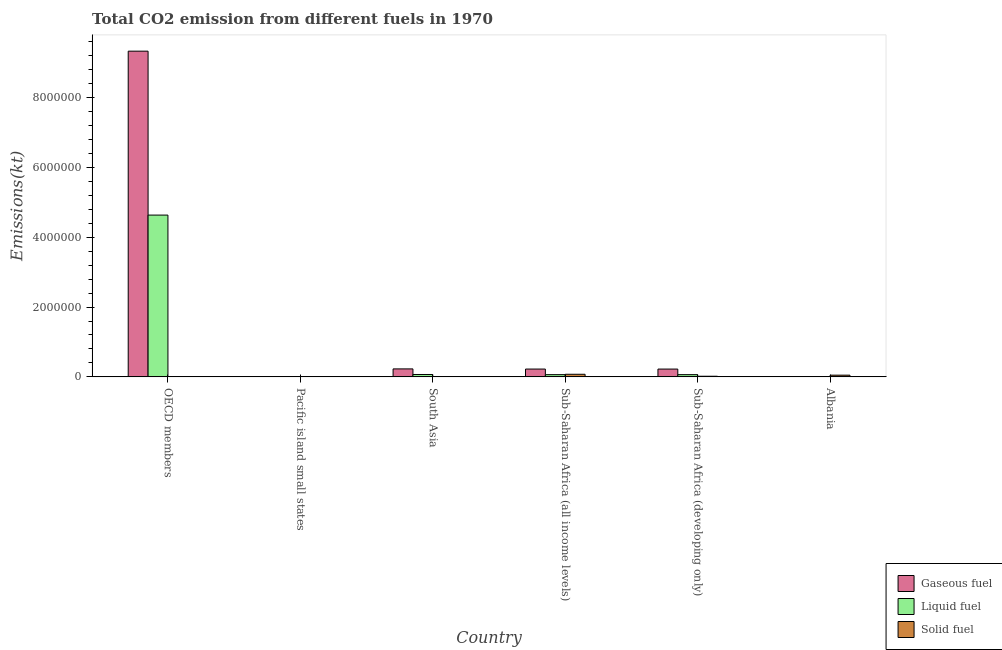How many groups of bars are there?
Give a very brief answer. 6. Are the number of bars on each tick of the X-axis equal?
Ensure brevity in your answer.  Yes. What is the label of the 6th group of bars from the left?
Your response must be concise. Albania. What is the amount of co2 emissions from liquid fuel in Albania?
Your answer should be very brief. 2482.56. Across all countries, what is the maximum amount of co2 emissions from liquid fuel?
Keep it short and to the point. 4.63e+06. Across all countries, what is the minimum amount of co2 emissions from liquid fuel?
Give a very brief answer. 864.69. In which country was the amount of co2 emissions from liquid fuel minimum?
Offer a terse response. Pacific island small states. What is the total amount of co2 emissions from gaseous fuel in the graph?
Provide a succinct answer. 1.00e+07. What is the difference between the amount of co2 emissions from gaseous fuel in South Asia and that in Sub-Saharan Africa (all income levels)?
Your answer should be compact. 4515.06. What is the difference between the amount of co2 emissions from solid fuel in Pacific island small states and the amount of co2 emissions from gaseous fuel in OECD members?
Your answer should be very brief. -9.33e+06. What is the average amount of co2 emissions from liquid fuel per country?
Your answer should be very brief. 8.06e+05. What is the difference between the amount of co2 emissions from liquid fuel and amount of co2 emissions from gaseous fuel in OECD members?
Provide a succinct answer. -4.70e+06. What is the ratio of the amount of co2 emissions from solid fuel in Pacific island small states to that in Sub-Saharan Africa (developing only)?
Provide a succinct answer. 0. What is the difference between the highest and the second highest amount of co2 emissions from liquid fuel?
Offer a very short reply. 4.57e+06. What is the difference between the highest and the lowest amount of co2 emissions from solid fuel?
Provide a succinct answer. 7.43e+04. In how many countries, is the amount of co2 emissions from gaseous fuel greater than the average amount of co2 emissions from gaseous fuel taken over all countries?
Provide a short and direct response. 1. What does the 1st bar from the left in Sub-Saharan Africa (developing only) represents?
Keep it short and to the point. Gaseous fuel. What does the 1st bar from the right in South Asia represents?
Make the answer very short. Solid fuel. Is it the case that in every country, the sum of the amount of co2 emissions from gaseous fuel and amount of co2 emissions from liquid fuel is greater than the amount of co2 emissions from solid fuel?
Give a very brief answer. No. How many bars are there?
Provide a succinct answer. 18. Are all the bars in the graph horizontal?
Keep it short and to the point. No. Does the graph contain grids?
Make the answer very short. No. How are the legend labels stacked?
Provide a short and direct response. Vertical. What is the title of the graph?
Provide a succinct answer. Total CO2 emission from different fuels in 1970. Does "Gaseous fuel" appear as one of the legend labels in the graph?
Your response must be concise. Yes. What is the label or title of the Y-axis?
Offer a very short reply. Emissions(kt). What is the Emissions(kt) in Gaseous fuel in OECD members?
Offer a very short reply. 9.33e+06. What is the Emissions(kt) in Liquid fuel in OECD members?
Keep it short and to the point. 4.63e+06. What is the Emissions(kt) of Solid fuel in OECD members?
Offer a very short reply. 971.75. What is the Emissions(kt) of Gaseous fuel in Pacific island small states?
Your answer should be very brief. 891.27. What is the Emissions(kt) in Liquid fuel in Pacific island small states?
Give a very brief answer. 864.69. What is the Emissions(kt) in Solid fuel in Pacific island small states?
Your answer should be compact. 47.67. What is the Emissions(kt) in Gaseous fuel in South Asia?
Offer a terse response. 2.28e+05. What is the Emissions(kt) of Liquid fuel in South Asia?
Ensure brevity in your answer.  6.83e+04. What is the Emissions(kt) of Solid fuel in South Asia?
Your response must be concise. 3289.3. What is the Emissions(kt) in Gaseous fuel in Sub-Saharan Africa (all income levels)?
Keep it short and to the point. 2.24e+05. What is the Emissions(kt) in Liquid fuel in Sub-Saharan Africa (all income levels)?
Your answer should be compact. 6.39e+04. What is the Emissions(kt) of Solid fuel in Sub-Saharan Africa (all income levels)?
Provide a short and direct response. 7.44e+04. What is the Emissions(kt) in Gaseous fuel in Sub-Saharan Africa (developing only)?
Provide a succinct answer. 2.24e+05. What is the Emissions(kt) in Liquid fuel in Sub-Saharan Africa (developing only)?
Ensure brevity in your answer.  6.38e+04. What is the Emissions(kt) in Solid fuel in Sub-Saharan Africa (developing only)?
Make the answer very short. 1.78e+04. What is the Emissions(kt) in Gaseous fuel in Albania?
Provide a short and direct response. 3744.01. What is the Emissions(kt) in Liquid fuel in Albania?
Your response must be concise. 2482.56. What is the Emissions(kt) in Solid fuel in Albania?
Make the answer very short. 4.90e+04. Across all countries, what is the maximum Emissions(kt) in Gaseous fuel?
Provide a succinct answer. 9.33e+06. Across all countries, what is the maximum Emissions(kt) in Liquid fuel?
Ensure brevity in your answer.  4.63e+06. Across all countries, what is the maximum Emissions(kt) in Solid fuel?
Make the answer very short. 7.44e+04. Across all countries, what is the minimum Emissions(kt) in Gaseous fuel?
Your answer should be compact. 891.27. Across all countries, what is the minimum Emissions(kt) of Liquid fuel?
Your answer should be very brief. 864.69. Across all countries, what is the minimum Emissions(kt) of Solid fuel?
Your answer should be very brief. 47.67. What is the total Emissions(kt) in Gaseous fuel in the graph?
Provide a succinct answer. 1.00e+07. What is the total Emissions(kt) of Liquid fuel in the graph?
Your answer should be very brief. 4.83e+06. What is the total Emissions(kt) of Solid fuel in the graph?
Ensure brevity in your answer.  1.46e+05. What is the difference between the Emissions(kt) of Gaseous fuel in OECD members and that in Pacific island small states?
Provide a succinct answer. 9.33e+06. What is the difference between the Emissions(kt) in Liquid fuel in OECD members and that in Pacific island small states?
Your response must be concise. 4.63e+06. What is the difference between the Emissions(kt) of Solid fuel in OECD members and that in Pacific island small states?
Make the answer very short. 924.08. What is the difference between the Emissions(kt) in Gaseous fuel in OECD members and that in South Asia?
Give a very brief answer. 9.10e+06. What is the difference between the Emissions(kt) in Liquid fuel in OECD members and that in South Asia?
Ensure brevity in your answer.  4.57e+06. What is the difference between the Emissions(kt) in Solid fuel in OECD members and that in South Asia?
Your answer should be compact. -2317.54. What is the difference between the Emissions(kt) of Gaseous fuel in OECD members and that in Sub-Saharan Africa (all income levels)?
Your answer should be compact. 9.11e+06. What is the difference between the Emissions(kt) in Liquid fuel in OECD members and that in Sub-Saharan Africa (all income levels)?
Your response must be concise. 4.57e+06. What is the difference between the Emissions(kt) of Solid fuel in OECD members and that in Sub-Saharan Africa (all income levels)?
Your answer should be very brief. -7.34e+04. What is the difference between the Emissions(kt) in Gaseous fuel in OECD members and that in Sub-Saharan Africa (developing only)?
Offer a terse response. 9.11e+06. What is the difference between the Emissions(kt) in Liquid fuel in OECD members and that in Sub-Saharan Africa (developing only)?
Provide a succinct answer. 4.57e+06. What is the difference between the Emissions(kt) in Solid fuel in OECD members and that in Sub-Saharan Africa (developing only)?
Make the answer very short. -1.68e+04. What is the difference between the Emissions(kt) in Gaseous fuel in OECD members and that in Albania?
Provide a succinct answer. 9.33e+06. What is the difference between the Emissions(kt) of Liquid fuel in OECD members and that in Albania?
Give a very brief answer. 4.63e+06. What is the difference between the Emissions(kt) of Solid fuel in OECD members and that in Albania?
Offer a very short reply. -4.81e+04. What is the difference between the Emissions(kt) in Gaseous fuel in Pacific island small states and that in South Asia?
Provide a short and direct response. -2.27e+05. What is the difference between the Emissions(kt) of Liquid fuel in Pacific island small states and that in South Asia?
Offer a very short reply. -6.74e+04. What is the difference between the Emissions(kt) in Solid fuel in Pacific island small states and that in South Asia?
Give a very brief answer. -3241.63. What is the difference between the Emissions(kt) of Gaseous fuel in Pacific island small states and that in Sub-Saharan Africa (all income levels)?
Your answer should be compact. -2.23e+05. What is the difference between the Emissions(kt) of Liquid fuel in Pacific island small states and that in Sub-Saharan Africa (all income levels)?
Offer a very short reply. -6.30e+04. What is the difference between the Emissions(kt) in Solid fuel in Pacific island small states and that in Sub-Saharan Africa (all income levels)?
Make the answer very short. -7.43e+04. What is the difference between the Emissions(kt) of Gaseous fuel in Pacific island small states and that in Sub-Saharan Africa (developing only)?
Make the answer very short. -2.23e+05. What is the difference between the Emissions(kt) of Liquid fuel in Pacific island small states and that in Sub-Saharan Africa (developing only)?
Provide a short and direct response. -6.30e+04. What is the difference between the Emissions(kt) in Solid fuel in Pacific island small states and that in Sub-Saharan Africa (developing only)?
Provide a short and direct response. -1.78e+04. What is the difference between the Emissions(kt) of Gaseous fuel in Pacific island small states and that in Albania?
Offer a terse response. -2852.74. What is the difference between the Emissions(kt) of Liquid fuel in Pacific island small states and that in Albania?
Your answer should be very brief. -1617.87. What is the difference between the Emissions(kt) of Solid fuel in Pacific island small states and that in Albania?
Provide a succinct answer. -4.90e+04. What is the difference between the Emissions(kt) in Gaseous fuel in South Asia and that in Sub-Saharan Africa (all income levels)?
Make the answer very short. 4515.06. What is the difference between the Emissions(kt) of Liquid fuel in South Asia and that in Sub-Saharan Africa (all income levels)?
Provide a succinct answer. 4375.04. What is the difference between the Emissions(kt) in Solid fuel in South Asia and that in Sub-Saharan Africa (all income levels)?
Keep it short and to the point. -7.11e+04. What is the difference between the Emissions(kt) of Gaseous fuel in South Asia and that in Sub-Saharan Africa (developing only)?
Make the answer very short. 4576.47. What is the difference between the Emissions(kt) of Liquid fuel in South Asia and that in Sub-Saharan Africa (developing only)?
Provide a succinct answer. 4437.73. What is the difference between the Emissions(kt) in Solid fuel in South Asia and that in Sub-Saharan Africa (developing only)?
Offer a terse response. -1.45e+04. What is the difference between the Emissions(kt) of Gaseous fuel in South Asia and that in Albania?
Keep it short and to the point. 2.25e+05. What is the difference between the Emissions(kt) of Liquid fuel in South Asia and that in Albania?
Provide a succinct answer. 6.58e+04. What is the difference between the Emissions(kt) of Solid fuel in South Asia and that in Albania?
Offer a very short reply. -4.57e+04. What is the difference between the Emissions(kt) of Gaseous fuel in Sub-Saharan Africa (all income levels) and that in Sub-Saharan Africa (developing only)?
Provide a succinct answer. 61.41. What is the difference between the Emissions(kt) of Liquid fuel in Sub-Saharan Africa (all income levels) and that in Sub-Saharan Africa (developing only)?
Make the answer very short. 62.69. What is the difference between the Emissions(kt) of Solid fuel in Sub-Saharan Africa (all income levels) and that in Sub-Saharan Africa (developing only)?
Offer a terse response. 5.65e+04. What is the difference between the Emissions(kt) of Gaseous fuel in Sub-Saharan Africa (all income levels) and that in Albania?
Ensure brevity in your answer.  2.20e+05. What is the difference between the Emissions(kt) in Liquid fuel in Sub-Saharan Africa (all income levels) and that in Albania?
Make the answer very short. 6.14e+04. What is the difference between the Emissions(kt) in Solid fuel in Sub-Saharan Africa (all income levels) and that in Albania?
Give a very brief answer. 2.53e+04. What is the difference between the Emissions(kt) of Gaseous fuel in Sub-Saharan Africa (developing only) and that in Albania?
Keep it short and to the point. 2.20e+05. What is the difference between the Emissions(kt) of Liquid fuel in Sub-Saharan Africa (developing only) and that in Albania?
Keep it short and to the point. 6.13e+04. What is the difference between the Emissions(kt) of Solid fuel in Sub-Saharan Africa (developing only) and that in Albania?
Keep it short and to the point. -3.12e+04. What is the difference between the Emissions(kt) in Gaseous fuel in OECD members and the Emissions(kt) in Liquid fuel in Pacific island small states?
Your answer should be very brief. 9.33e+06. What is the difference between the Emissions(kt) in Gaseous fuel in OECD members and the Emissions(kt) in Solid fuel in Pacific island small states?
Your answer should be very brief. 9.33e+06. What is the difference between the Emissions(kt) in Liquid fuel in OECD members and the Emissions(kt) in Solid fuel in Pacific island small states?
Ensure brevity in your answer.  4.63e+06. What is the difference between the Emissions(kt) of Gaseous fuel in OECD members and the Emissions(kt) of Liquid fuel in South Asia?
Your answer should be very brief. 9.26e+06. What is the difference between the Emissions(kt) in Gaseous fuel in OECD members and the Emissions(kt) in Solid fuel in South Asia?
Give a very brief answer. 9.33e+06. What is the difference between the Emissions(kt) of Liquid fuel in OECD members and the Emissions(kt) of Solid fuel in South Asia?
Your answer should be compact. 4.63e+06. What is the difference between the Emissions(kt) of Gaseous fuel in OECD members and the Emissions(kt) of Liquid fuel in Sub-Saharan Africa (all income levels)?
Provide a succinct answer. 9.27e+06. What is the difference between the Emissions(kt) of Gaseous fuel in OECD members and the Emissions(kt) of Solid fuel in Sub-Saharan Africa (all income levels)?
Offer a very short reply. 9.26e+06. What is the difference between the Emissions(kt) in Liquid fuel in OECD members and the Emissions(kt) in Solid fuel in Sub-Saharan Africa (all income levels)?
Provide a short and direct response. 4.56e+06. What is the difference between the Emissions(kt) in Gaseous fuel in OECD members and the Emissions(kt) in Liquid fuel in Sub-Saharan Africa (developing only)?
Provide a short and direct response. 9.27e+06. What is the difference between the Emissions(kt) of Gaseous fuel in OECD members and the Emissions(kt) of Solid fuel in Sub-Saharan Africa (developing only)?
Give a very brief answer. 9.31e+06. What is the difference between the Emissions(kt) of Liquid fuel in OECD members and the Emissions(kt) of Solid fuel in Sub-Saharan Africa (developing only)?
Your answer should be compact. 4.62e+06. What is the difference between the Emissions(kt) of Gaseous fuel in OECD members and the Emissions(kt) of Liquid fuel in Albania?
Your answer should be compact. 9.33e+06. What is the difference between the Emissions(kt) in Gaseous fuel in OECD members and the Emissions(kt) in Solid fuel in Albania?
Ensure brevity in your answer.  9.28e+06. What is the difference between the Emissions(kt) in Liquid fuel in OECD members and the Emissions(kt) in Solid fuel in Albania?
Offer a very short reply. 4.59e+06. What is the difference between the Emissions(kt) in Gaseous fuel in Pacific island small states and the Emissions(kt) in Liquid fuel in South Asia?
Provide a short and direct response. -6.74e+04. What is the difference between the Emissions(kt) of Gaseous fuel in Pacific island small states and the Emissions(kt) of Solid fuel in South Asia?
Your answer should be compact. -2398.03. What is the difference between the Emissions(kt) of Liquid fuel in Pacific island small states and the Emissions(kt) of Solid fuel in South Asia?
Make the answer very short. -2424.61. What is the difference between the Emissions(kt) in Gaseous fuel in Pacific island small states and the Emissions(kt) in Liquid fuel in Sub-Saharan Africa (all income levels)?
Keep it short and to the point. -6.30e+04. What is the difference between the Emissions(kt) in Gaseous fuel in Pacific island small states and the Emissions(kt) in Solid fuel in Sub-Saharan Africa (all income levels)?
Offer a terse response. -7.35e+04. What is the difference between the Emissions(kt) in Liquid fuel in Pacific island small states and the Emissions(kt) in Solid fuel in Sub-Saharan Africa (all income levels)?
Ensure brevity in your answer.  -7.35e+04. What is the difference between the Emissions(kt) in Gaseous fuel in Pacific island small states and the Emissions(kt) in Liquid fuel in Sub-Saharan Africa (developing only)?
Provide a succinct answer. -6.29e+04. What is the difference between the Emissions(kt) in Gaseous fuel in Pacific island small states and the Emissions(kt) in Solid fuel in Sub-Saharan Africa (developing only)?
Provide a short and direct response. -1.69e+04. What is the difference between the Emissions(kt) of Liquid fuel in Pacific island small states and the Emissions(kt) of Solid fuel in Sub-Saharan Africa (developing only)?
Provide a succinct answer. -1.69e+04. What is the difference between the Emissions(kt) in Gaseous fuel in Pacific island small states and the Emissions(kt) in Liquid fuel in Albania?
Make the answer very short. -1591.29. What is the difference between the Emissions(kt) in Gaseous fuel in Pacific island small states and the Emissions(kt) in Solid fuel in Albania?
Your answer should be compact. -4.81e+04. What is the difference between the Emissions(kt) in Liquid fuel in Pacific island small states and the Emissions(kt) in Solid fuel in Albania?
Ensure brevity in your answer.  -4.82e+04. What is the difference between the Emissions(kt) in Gaseous fuel in South Asia and the Emissions(kt) in Liquid fuel in Sub-Saharan Africa (all income levels)?
Your answer should be compact. 1.64e+05. What is the difference between the Emissions(kt) in Gaseous fuel in South Asia and the Emissions(kt) in Solid fuel in Sub-Saharan Africa (all income levels)?
Offer a very short reply. 1.54e+05. What is the difference between the Emissions(kt) in Liquid fuel in South Asia and the Emissions(kt) in Solid fuel in Sub-Saharan Africa (all income levels)?
Keep it short and to the point. -6091.52. What is the difference between the Emissions(kt) in Gaseous fuel in South Asia and the Emissions(kt) in Liquid fuel in Sub-Saharan Africa (developing only)?
Provide a succinct answer. 1.64e+05. What is the difference between the Emissions(kt) in Gaseous fuel in South Asia and the Emissions(kt) in Solid fuel in Sub-Saharan Africa (developing only)?
Offer a very short reply. 2.10e+05. What is the difference between the Emissions(kt) in Liquid fuel in South Asia and the Emissions(kt) in Solid fuel in Sub-Saharan Africa (developing only)?
Provide a succinct answer. 5.04e+04. What is the difference between the Emissions(kt) in Gaseous fuel in South Asia and the Emissions(kt) in Liquid fuel in Albania?
Give a very brief answer. 2.26e+05. What is the difference between the Emissions(kt) of Gaseous fuel in South Asia and the Emissions(kt) of Solid fuel in Albania?
Your answer should be very brief. 1.79e+05. What is the difference between the Emissions(kt) in Liquid fuel in South Asia and the Emissions(kt) in Solid fuel in Albania?
Ensure brevity in your answer.  1.92e+04. What is the difference between the Emissions(kt) of Gaseous fuel in Sub-Saharan Africa (all income levels) and the Emissions(kt) of Liquid fuel in Sub-Saharan Africa (developing only)?
Ensure brevity in your answer.  1.60e+05. What is the difference between the Emissions(kt) in Gaseous fuel in Sub-Saharan Africa (all income levels) and the Emissions(kt) in Solid fuel in Sub-Saharan Africa (developing only)?
Offer a very short reply. 2.06e+05. What is the difference between the Emissions(kt) of Liquid fuel in Sub-Saharan Africa (all income levels) and the Emissions(kt) of Solid fuel in Sub-Saharan Africa (developing only)?
Provide a succinct answer. 4.61e+04. What is the difference between the Emissions(kt) of Gaseous fuel in Sub-Saharan Africa (all income levels) and the Emissions(kt) of Liquid fuel in Albania?
Provide a succinct answer. 2.21e+05. What is the difference between the Emissions(kt) of Gaseous fuel in Sub-Saharan Africa (all income levels) and the Emissions(kt) of Solid fuel in Albania?
Keep it short and to the point. 1.75e+05. What is the difference between the Emissions(kt) in Liquid fuel in Sub-Saharan Africa (all income levels) and the Emissions(kt) in Solid fuel in Albania?
Your answer should be very brief. 1.49e+04. What is the difference between the Emissions(kt) in Gaseous fuel in Sub-Saharan Africa (developing only) and the Emissions(kt) in Liquid fuel in Albania?
Ensure brevity in your answer.  2.21e+05. What is the difference between the Emissions(kt) of Gaseous fuel in Sub-Saharan Africa (developing only) and the Emissions(kt) of Solid fuel in Albania?
Offer a very short reply. 1.75e+05. What is the difference between the Emissions(kt) in Liquid fuel in Sub-Saharan Africa (developing only) and the Emissions(kt) in Solid fuel in Albania?
Keep it short and to the point. 1.48e+04. What is the average Emissions(kt) in Gaseous fuel per country?
Offer a terse response. 1.67e+06. What is the average Emissions(kt) in Liquid fuel per country?
Your answer should be compact. 8.06e+05. What is the average Emissions(kt) in Solid fuel per country?
Your answer should be very brief. 2.43e+04. What is the difference between the Emissions(kt) of Gaseous fuel and Emissions(kt) of Liquid fuel in OECD members?
Ensure brevity in your answer.  4.70e+06. What is the difference between the Emissions(kt) of Gaseous fuel and Emissions(kt) of Solid fuel in OECD members?
Your answer should be compact. 9.33e+06. What is the difference between the Emissions(kt) in Liquid fuel and Emissions(kt) in Solid fuel in OECD members?
Give a very brief answer. 4.63e+06. What is the difference between the Emissions(kt) of Gaseous fuel and Emissions(kt) of Liquid fuel in Pacific island small states?
Offer a terse response. 26.58. What is the difference between the Emissions(kt) in Gaseous fuel and Emissions(kt) in Solid fuel in Pacific island small states?
Your answer should be very brief. 843.6. What is the difference between the Emissions(kt) of Liquid fuel and Emissions(kt) of Solid fuel in Pacific island small states?
Keep it short and to the point. 817.02. What is the difference between the Emissions(kt) of Gaseous fuel and Emissions(kt) of Liquid fuel in South Asia?
Your answer should be very brief. 1.60e+05. What is the difference between the Emissions(kt) of Gaseous fuel and Emissions(kt) of Solid fuel in South Asia?
Make the answer very short. 2.25e+05. What is the difference between the Emissions(kt) of Liquid fuel and Emissions(kt) of Solid fuel in South Asia?
Ensure brevity in your answer.  6.50e+04. What is the difference between the Emissions(kt) in Gaseous fuel and Emissions(kt) in Liquid fuel in Sub-Saharan Africa (all income levels)?
Your answer should be very brief. 1.60e+05. What is the difference between the Emissions(kt) in Gaseous fuel and Emissions(kt) in Solid fuel in Sub-Saharan Africa (all income levels)?
Keep it short and to the point. 1.49e+05. What is the difference between the Emissions(kt) in Liquid fuel and Emissions(kt) in Solid fuel in Sub-Saharan Africa (all income levels)?
Provide a short and direct response. -1.05e+04. What is the difference between the Emissions(kt) of Gaseous fuel and Emissions(kt) of Liquid fuel in Sub-Saharan Africa (developing only)?
Provide a succinct answer. 1.60e+05. What is the difference between the Emissions(kt) of Gaseous fuel and Emissions(kt) of Solid fuel in Sub-Saharan Africa (developing only)?
Your answer should be compact. 2.06e+05. What is the difference between the Emissions(kt) in Liquid fuel and Emissions(kt) in Solid fuel in Sub-Saharan Africa (developing only)?
Keep it short and to the point. 4.60e+04. What is the difference between the Emissions(kt) in Gaseous fuel and Emissions(kt) in Liquid fuel in Albania?
Give a very brief answer. 1261.45. What is the difference between the Emissions(kt) in Gaseous fuel and Emissions(kt) in Solid fuel in Albania?
Your answer should be compact. -4.53e+04. What is the difference between the Emissions(kt) of Liquid fuel and Emissions(kt) of Solid fuel in Albania?
Offer a terse response. -4.66e+04. What is the ratio of the Emissions(kt) in Gaseous fuel in OECD members to that in Pacific island small states?
Offer a very short reply. 1.05e+04. What is the ratio of the Emissions(kt) in Liquid fuel in OECD members to that in Pacific island small states?
Offer a very short reply. 5359.9. What is the ratio of the Emissions(kt) of Solid fuel in OECD members to that in Pacific island small states?
Provide a succinct answer. 20.38. What is the ratio of the Emissions(kt) of Gaseous fuel in OECD members to that in South Asia?
Your response must be concise. 40.88. What is the ratio of the Emissions(kt) in Liquid fuel in OECD members to that in South Asia?
Offer a terse response. 67.89. What is the ratio of the Emissions(kt) of Solid fuel in OECD members to that in South Asia?
Offer a very short reply. 0.3. What is the ratio of the Emissions(kt) in Gaseous fuel in OECD members to that in Sub-Saharan Africa (all income levels)?
Provide a succinct answer. 41.7. What is the ratio of the Emissions(kt) of Liquid fuel in OECD members to that in Sub-Saharan Africa (all income levels)?
Offer a very short reply. 72.54. What is the ratio of the Emissions(kt) of Solid fuel in OECD members to that in Sub-Saharan Africa (all income levels)?
Your response must be concise. 0.01. What is the ratio of the Emissions(kt) of Gaseous fuel in OECD members to that in Sub-Saharan Africa (developing only)?
Provide a succinct answer. 41.71. What is the ratio of the Emissions(kt) in Liquid fuel in OECD members to that in Sub-Saharan Africa (developing only)?
Provide a short and direct response. 72.61. What is the ratio of the Emissions(kt) of Solid fuel in OECD members to that in Sub-Saharan Africa (developing only)?
Provide a succinct answer. 0.05. What is the ratio of the Emissions(kt) in Gaseous fuel in OECD members to that in Albania?
Provide a short and direct response. 2492.05. What is the ratio of the Emissions(kt) of Liquid fuel in OECD members to that in Albania?
Provide a succinct answer. 1866.88. What is the ratio of the Emissions(kt) in Solid fuel in OECD members to that in Albania?
Ensure brevity in your answer.  0.02. What is the ratio of the Emissions(kt) in Gaseous fuel in Pacific island small states to that in South Asia?
Provide a short and direct response. 0. What is the ratio of the Emissions(kt) of Liquid fuel in Pacific island small states to that in South Asia?
Ensure brevity in your answer.  0.01. What is the ratio of the Emissions(kt) in Solid fuel in Pacific island small states to that in South Asia?
Give a very brief answer. 0.01. What is the ratio of the Emissions(kt) of Gaseous fuel in Pacific island small states to that in Sub-Saharan Africa (all income levels)?
Keep it short and to the point. 0. What is the ratio of the Emissions(kt) in Liquid fuel in Pacific island small states to that in Sub-Saharan Africa (all income levels)?
Provide a succinct answer. 0.01. What is the ratio of the Emissions(kt) of Solid fuel in Pacific island small states to that in Sub-Saharan Africa (all income levels)?
Provide a short and direct response. 0. What is the ratio of the Emissions(kt) of Gaseous fuel in Pacific island small states to that in Sub-Saharan Africa (developing only)?
Offer a terse response. 0. What is the ratio of the Emissions(kt) of Liquid fuel in Pacific island small states to that in Sub-Saharan Africa (developing only)?
Ensure brevity in your answer.  0.01. What is the ratio of the Emissions(kt) of Solid fuel in Pacific island small states to that in Sub-Saharan Africa (developing only)?
Provide a short and direct response. 0. What is the ratio of the Emissions(kt) of Gaseous fuel in Pacific island small states to that in Albania?
Give a very brief answer. 0.24. What is the ratio of the Emissions(kt) of Liquid fuel in Pacific island small states to that in Albania?
Offer a very short reply. 0.35. What is the ratio of the Emissions(kt) of Gaseous fuel in South Asia to that in Sub-Saharan Africa (all income levels)?
Make the answer very short. 1.02. What is the ratio of the Emissions(kt) of Liquid fuel in South Asia to that in Sub-Saharan Africa (all income levels)?
Offer a very short reply. 1.07. What is the ratio of the Emissions(kt) in Solid fuel in South Asia to that in Sub-Saharan Africa (all income levels)?
Ensure brevity in your answer.  0.04. What is the ratio of the Emissions(kt) of Gaseous fuel in South Asia to that in Sub-Saharan Africa (developing only)?
Offer a very short reply. 1.02. What is the ratio of the Emissions(kt) in Liquid fuel in South Asia to that in Sub-Saharan Africa (developing only)?
Provide a succinct answer. 1.07. What is the ratio of the Emissions(kt) in Solid fuel in South Asia to that in Sub-Saharan Africa (developing only)?
Your answer should be very brief. 0.18. What is the ratio of the Emissions(kt) of Gaseous fuel in South Asia to that in Albania?
Ensure brevity in your answer.  60.96. What is the ratio of the Emissions(kt) of Liquid fuel in South Asia to that in Albania?
Ensure brevity in your answer.  27.5. What is the ratio of the Emissions(kt) in Solid fuel in South Asia to that in Albania?
Ensure brevity in your answer.  0.07. What is the ratio of the Emissions(kt) of Gaseous fuel in Sub-Saharan Africa (all income levels) to that in Sub-Saharan Africa (developing only)?
Provide a succinct answer. 1. What is the ratio of the Emissions(kt) of Liquid fuel in Sub-Saharan Africa (all income levels) to that in Sub-Saharan Africa (developing only)?
Your answer should be compact. 1. What is the ratio of the Emissions(kt) in Solid fuel in Sub-Saharan Africa (all income levels) to that in Sub-Saharan Africa (developing only)?
Your response must be concise. 4.17. What is the ratio of the Emissions(kt) in Gaseous fuel in Sub-Saharan Africa (all income levels) to that in Albania?
Your answer should be very brief. 59.76. What is the ratio of the Emissions(kt) of Liquid fuel in Sub-Saharan Africa (all income levels) to that in Albania?
Offer a very short reply. 25.74. What is the ratio of the Emissions(kt) in Solid fuel in Sub-Saharan Africa (all income levels) to that in Albania?
Your answer should be very brief. 1.52. What is the ratio of the Emissions(kt) of Gaseous fuel in Sub-Saharan Africa (developing only) to that in Albania?
Your response must be concise. 59.74. What is the ratio of the Emissions(kt) of Liquid fuel in Sub-Saharan Africa (developing only) to that in Albania?
Your answer should be compact. 25.71. What is the ratio of the Emissions(kt) in Solid fuel in Sub-Saharan Africa (developing only) to that in Albania?
Make the answer very short. 0.36. What is the difference between the highest and the second highest Emissions(kt) in Gaseous fuel?
Ensure brevity in your answer.  9.10e+06. What is the difference between the highest and the second highest Emissions(kt) in Liquid fuel?
Keep it short and to the point. 4.57e+06. What is the difference between the highest and the second highest Emissions(kt) of Solid fuel?
Your answer should be compact. 2.53e+04. What is the difference between the highest and the lowest Emissions(kt) of Gaseous fuel?
Give a very brief answer. 9.33e+06. What is the difference between the highest and the lowest Emissions(kt) in Liquid fuel?
Your answer should be compact. 4.63e+06. What is the difference between the highest and the lowest Emissions(kt) in Solid fuel?
Your response must be concise. 7.43e+04. 